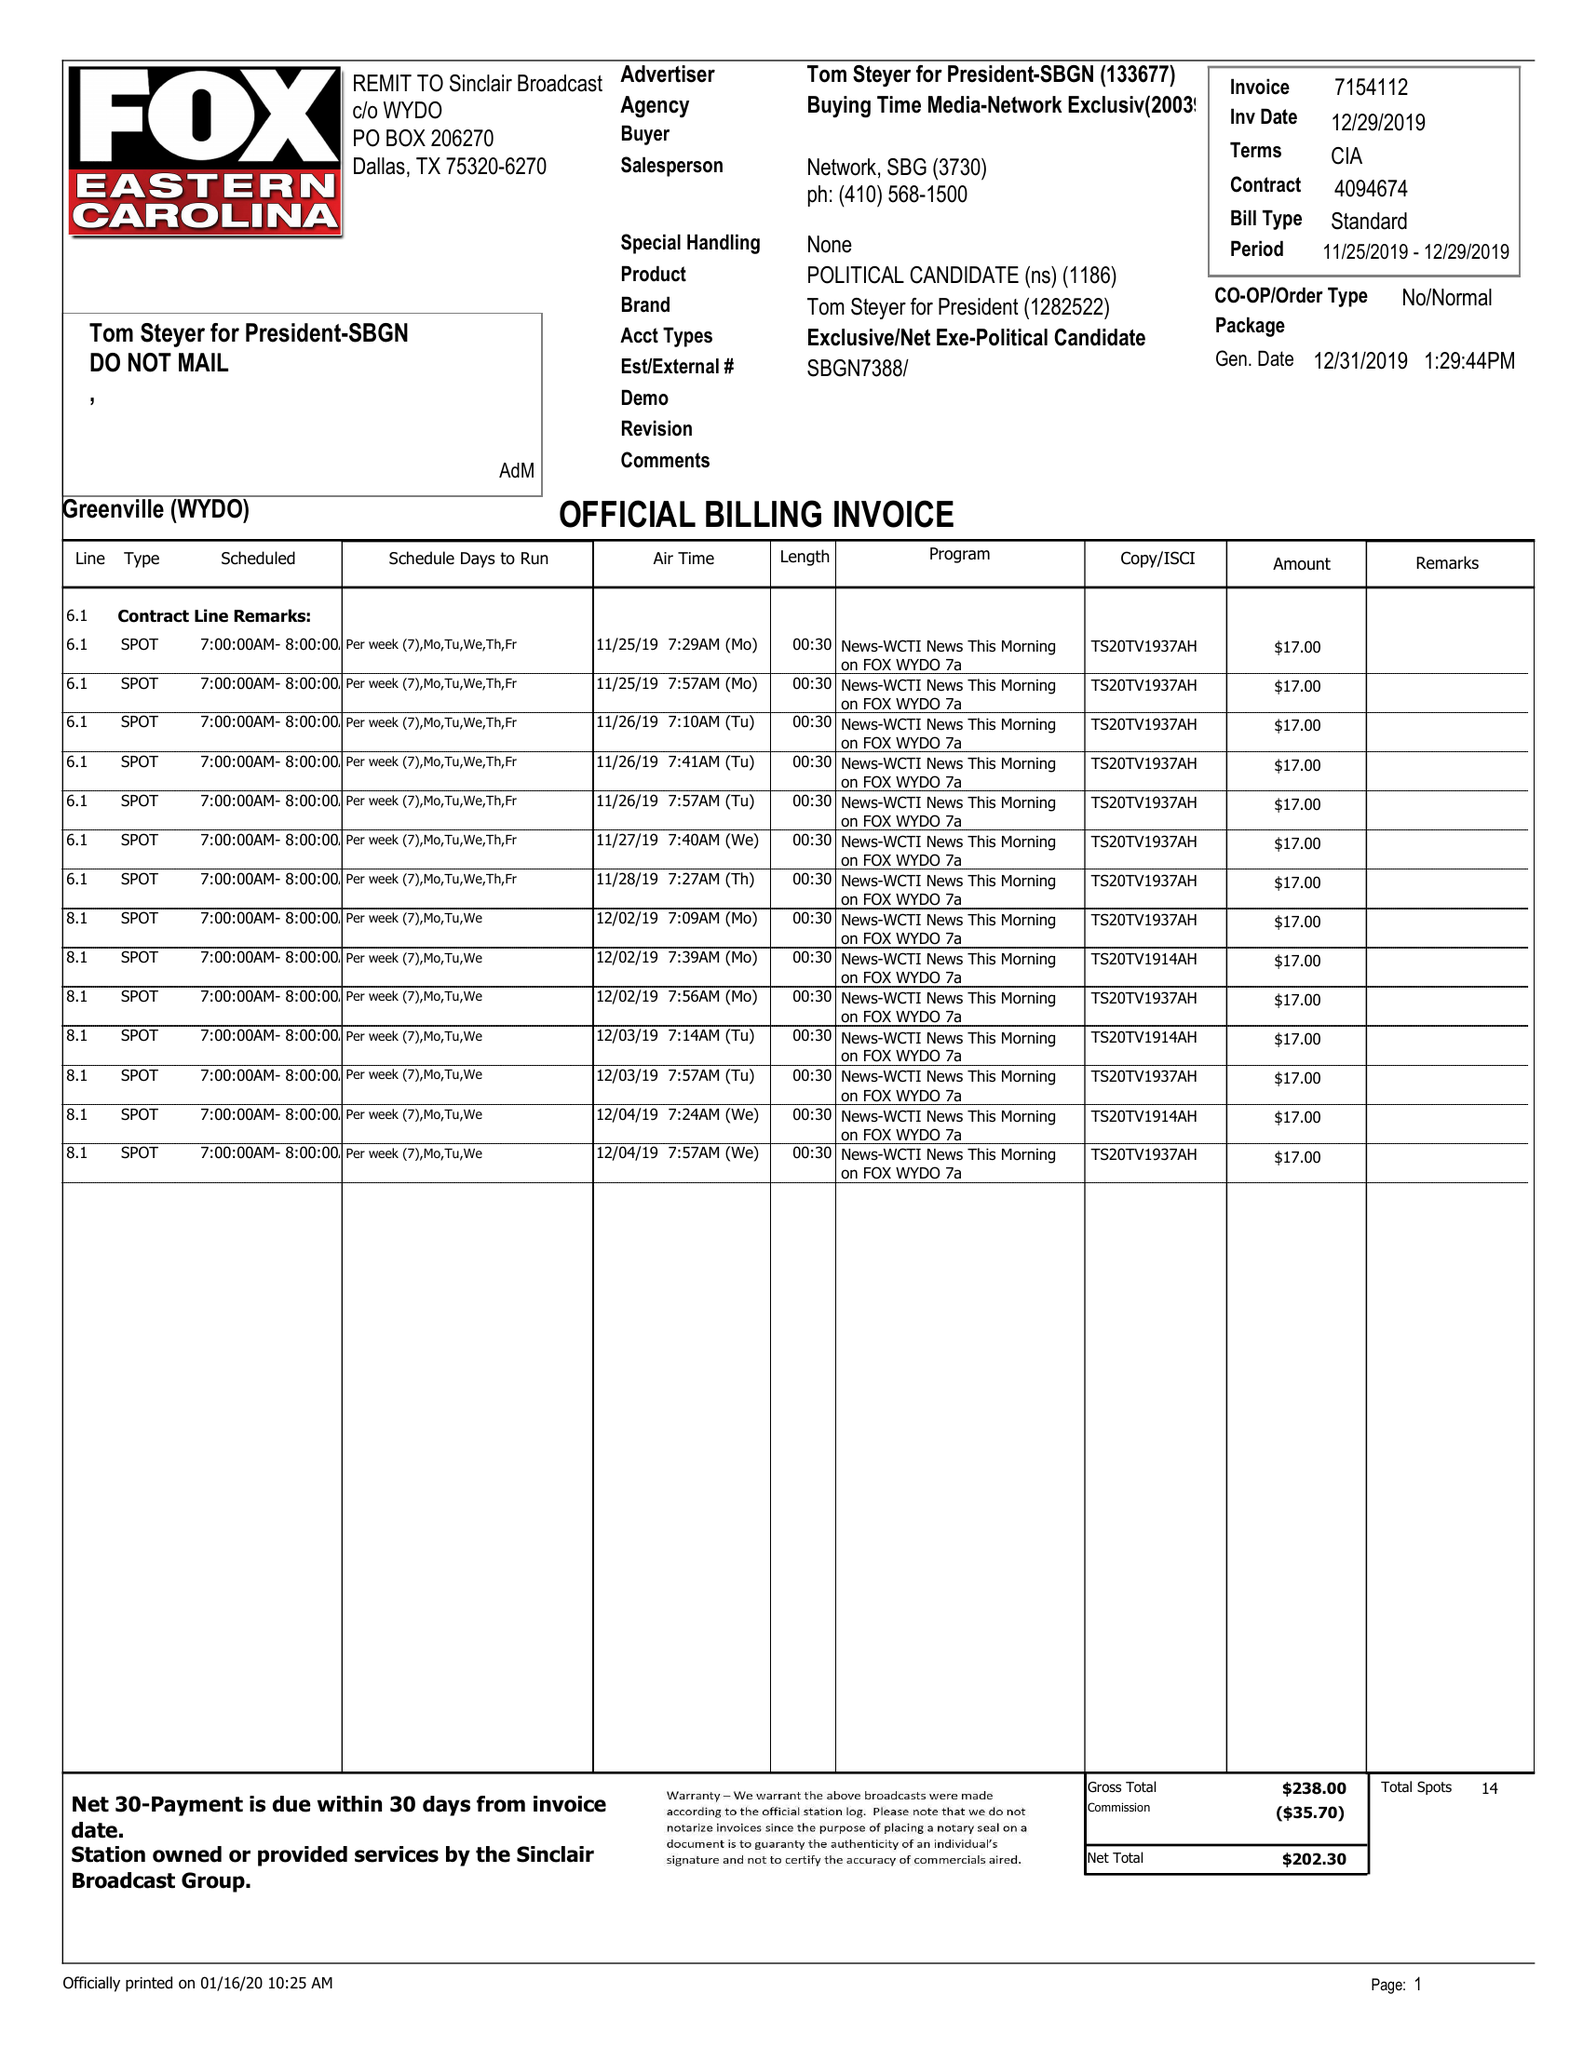What is the value for the flight_to?
Answer the question using a single word or phrase. 12/29/20 